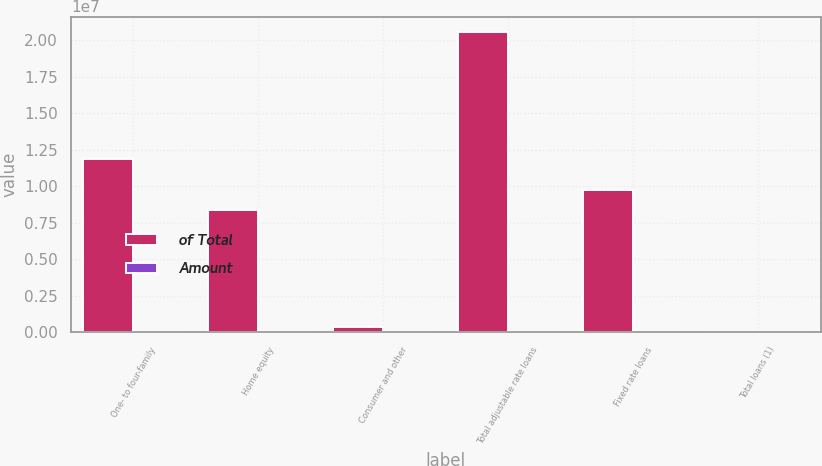<chart> <loc_0><loc_0><loc_500><loc_500><stacked_bar_chart><ecel><fcel>One- to four-family<fcel>Home equity<fcel>Consumer and other<fcel>Total adjustable rate loans<fcel>Fixed rate loans<fcel>Total loans (1)<nl><fcel>of Total<fcel>1.18532e+07<fcel>8.36786e+06<fcel>363482<fcel>2.05846e+07<fcel>9.74748e+06<fcel>100<nl><fcel>Amount<fcel>39.1<fcel>27.6<fcel>1.2<fcel>67.9<fcel>32.1<fcel>100<nl></chart> 